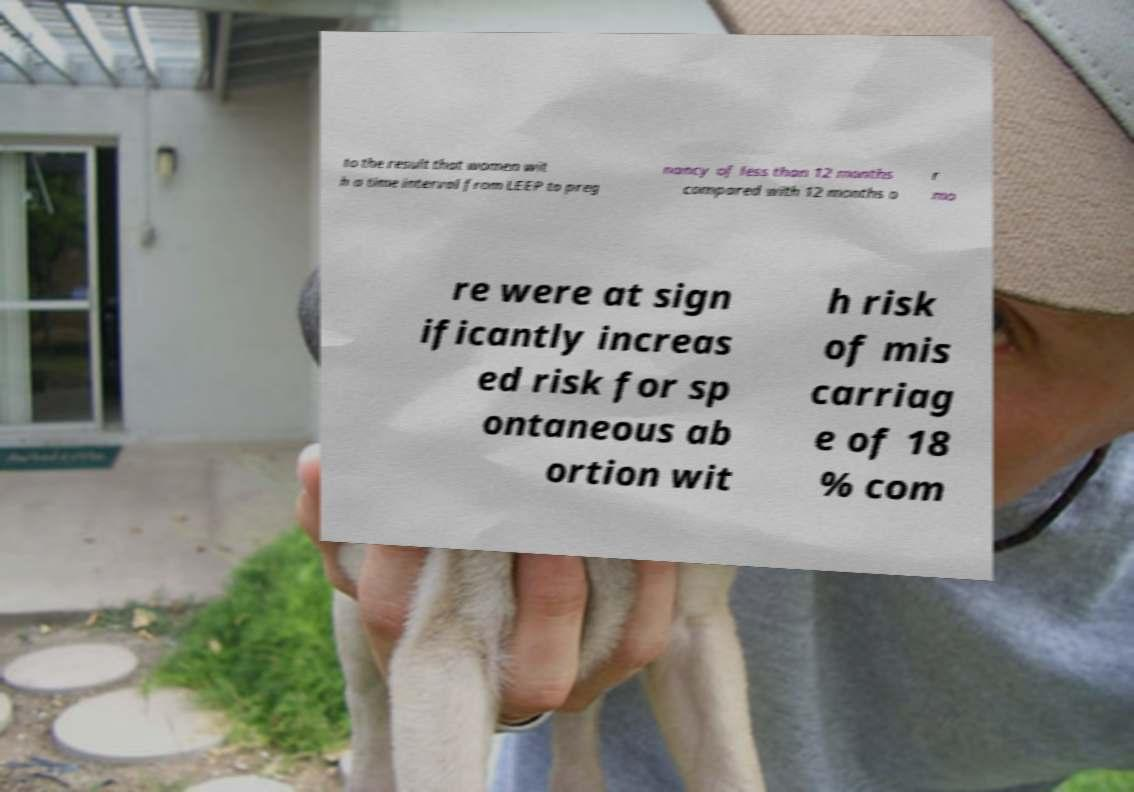I need the written content from this picture converted into text. Can you do that? to the result that women wit h a time interval from LEEP to preg nancy of less than 12 months compared with 12 months o r mo re were at sign ificantly increas ed risk for sp ontaneous ab ortion wit h risk of mis carriag e of 18 % com 